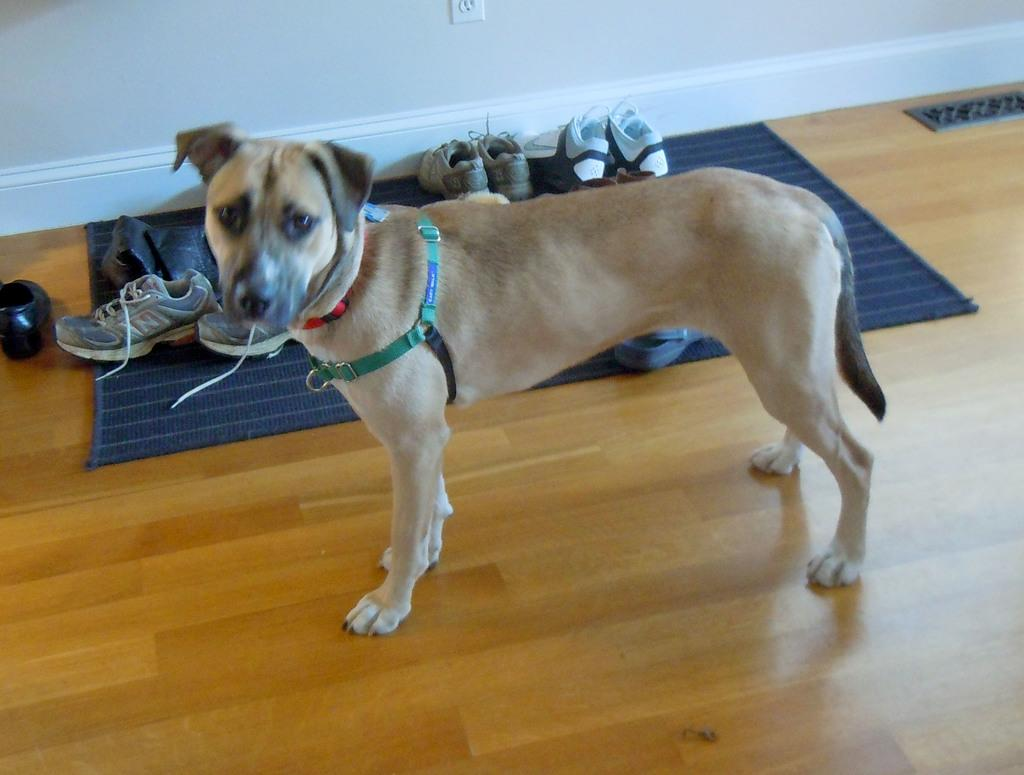What type of animal is in the image? There is a dog in the image. Where is the dog located? The dog is on the floor. What is on the floor near the dog? There is a mat in the image. What is on the mat? There are shoes on the mat. What can be seen in the background of the image? There is a wall visible in the background of the image. What does the dog's father look like in the image? There is no information about the dog's father in the image, as it only shows the dog, a mat, shoes, and a wall in the background. 